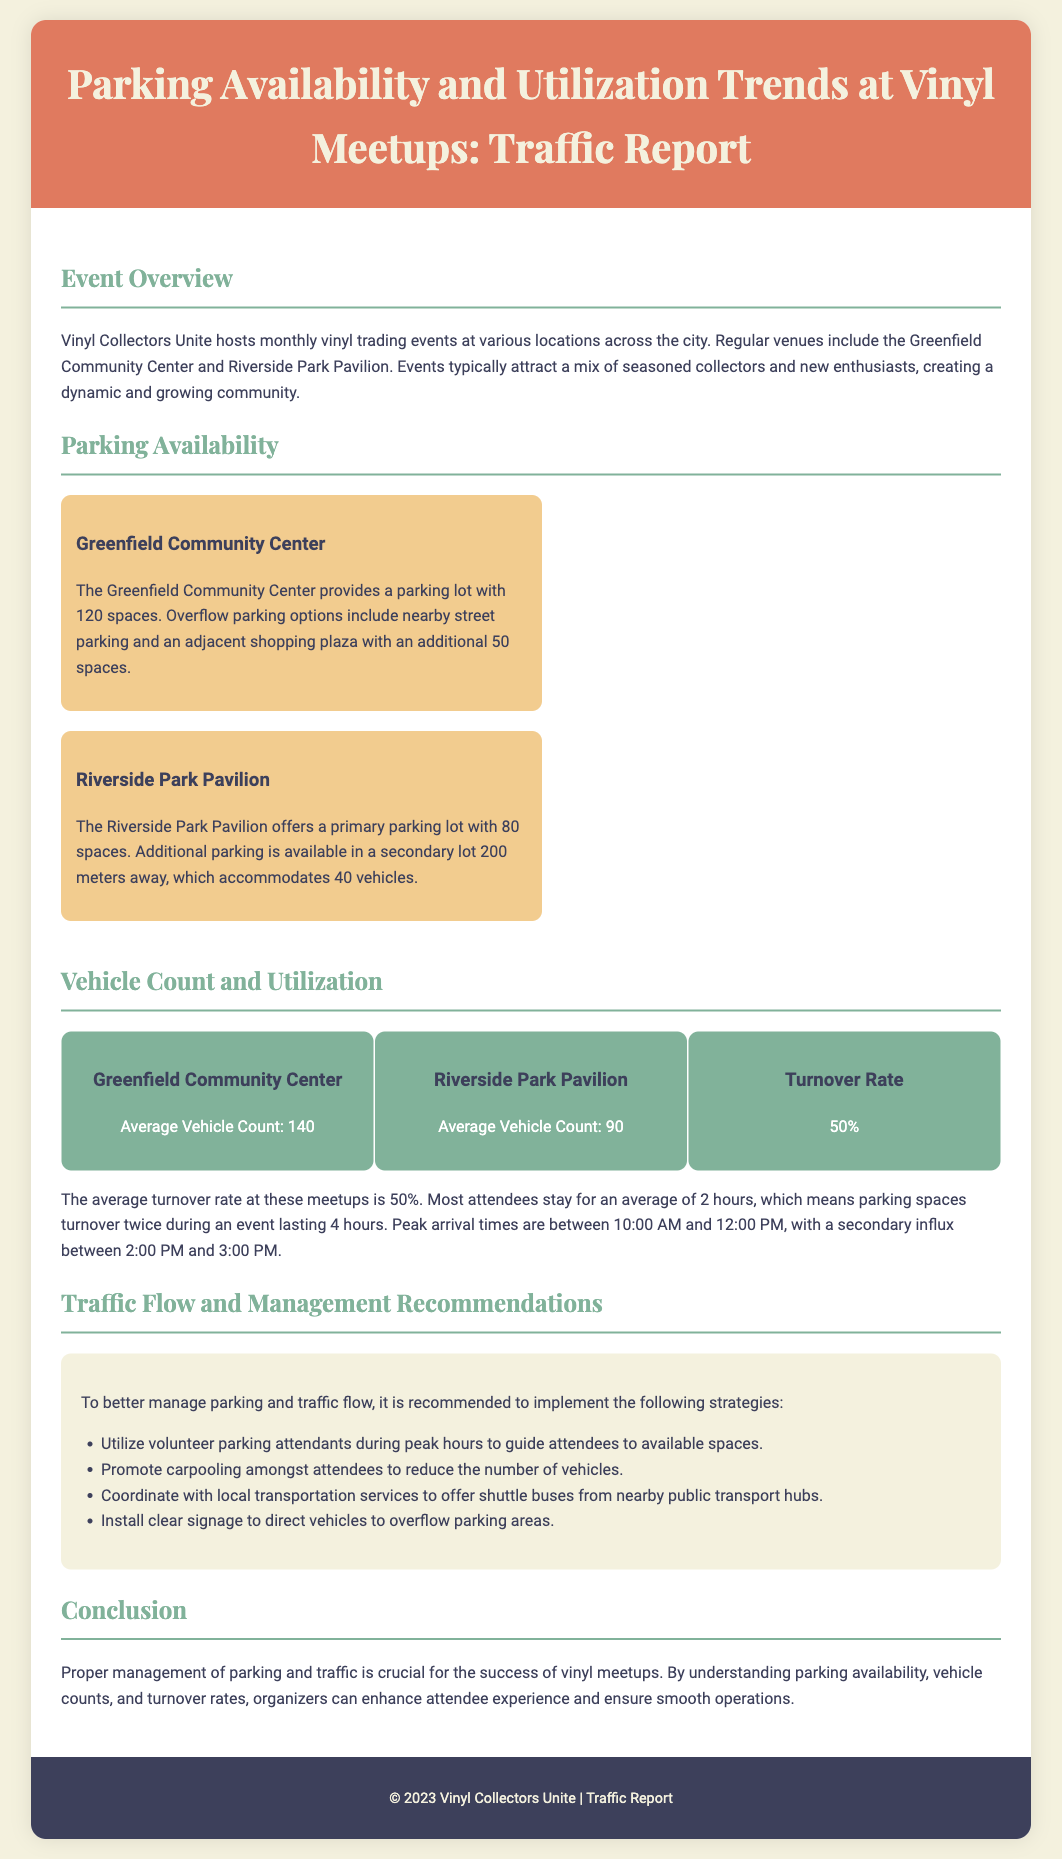What is the average vehicle count at the Greenfield Community Center? The document states that the average vehicle count is 140 at the Greenfield Community Center.
Answer: 140 What is the primary parking capacity at Riverside Park Pavilion? The document specifies that the primary parking capacity at Riverside Park Pavilion is 80 spaces.
Answer: 80 spaces What is the average turnover rate for parking at these meetups? The turnover rate mentioned in the document is 50%.
Answer: 50% How many total parking spaces are available near the Greenfield Community Center? The total parking spaces include 120 in the lot and 50 in the shopping plaza, making a total of 170 spaces.
Answer: 170 spaces During which hours do peak arrivals occur? The document indicates that peak arrival times are between 10:00 AM and 12:00 PM, with a secondary influx between 2:00 PM and 3:00 PM.
Answer: 10:00 AM to 12:00 PM What recommendations are made for managing parking? Recommendations include utilizing volunteer parking attendants, promoting carpooling, coordinating with local transportation services, and installing clear signage.
Answer: Utilize volunteer parking attendants What is the average duration attendees stay at the events? The document states that attendees stay for an average of 2 hours.
Answer: 2 hours What is the name of the organization hosting the vinyl meetups? The document identifies the organization as Vinyl Collectors Unite.
Answer: Vinyl Collectors Unite 